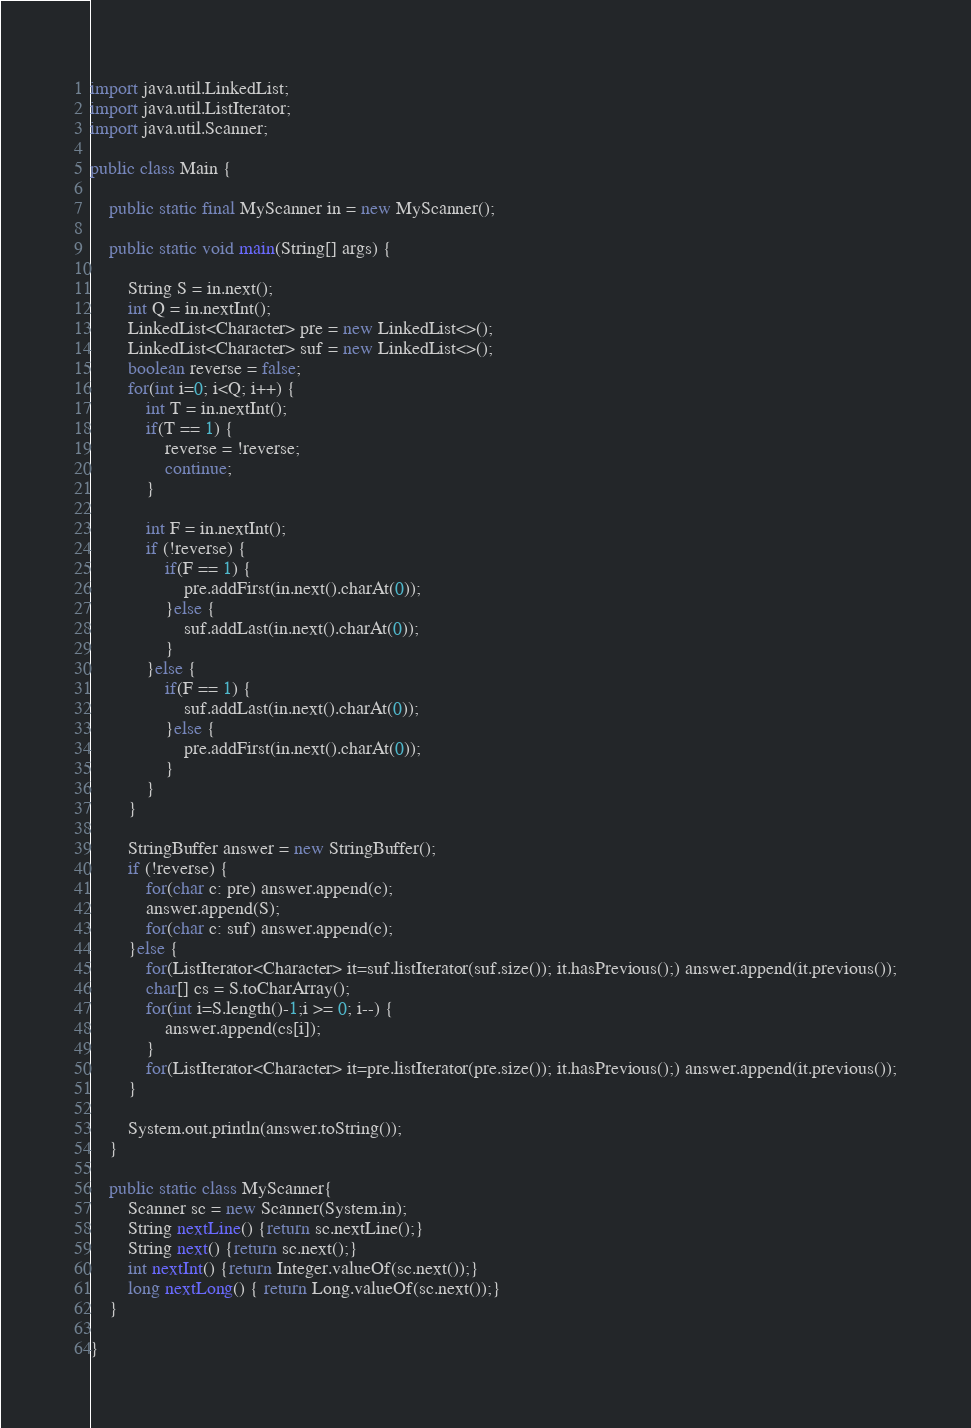Convert code to text. <code><loc_0><loc_0><loc_500><loc_500><_Java_>import java.util.LinkedList;
import java.util.ListIterator;
import java.util.Scanner;
 
public class Main {
 
	public static final MyScanner in = new MyScanner();
 
	public static void main(String[] args) {
 
		String S = in.next();
		int Q = in.nextInt();
		LinkedList<Character> pre = new LinkedList<>();
		LinkedList<Character> suf = new LinkedList<>();
		boolean reverse = false;
		for(int i=0; i<Q; i++) {
			int T = in.nextInt();
			if(T == 1) {
				reverse = !reverse;
				continue;
			}

			int F = in.nextInt();
			if (!reverse) {
				if(F == 1) {
					pre.addFirst(in.next().charAt(0));
				}else {
					suf.addLast(in.next().charAt(0));
				}
			}else {
				if(F == 1) {
					suf.addLast(in.next().charAt(0));
				}else {
					pre.addFirst(in.next().charAt(0));
				}
			}
		}

		StringBuffer answer = new StringBuffer();
		if (!reverse) {
			for(char c: pre) answer.append(c);
			answer.append(S);
			for(char c: suf) answer.append(c);
		}else {
			for(ListIterator<Character> it=suf.listIterator(suf.size()); it.hasPrevious();) answer.append(it.previous());
			char[] cs = S.toCharArray();
			for(int i=S.length()-1;i >= 0; i--) {
				answer.append(cs[i]);
			}
			for(ListIterator<Character> it=pre.listIterator(pre.size()); it.hasPrevious();) answer.append(it.previous());
		}

		System.out.println(answer.toString());
	}

	public static class MyScanner{
		Scanner sc = new Scanner(System.in);
		String nextLine() {return sc.nextLine();}
		String next() {return sc.next();}
		int nextInt() {return Integer.valueOf(sc.next());}
		long nextLong() { return Long.valueOf(sc.next());}
	}

}</code> 